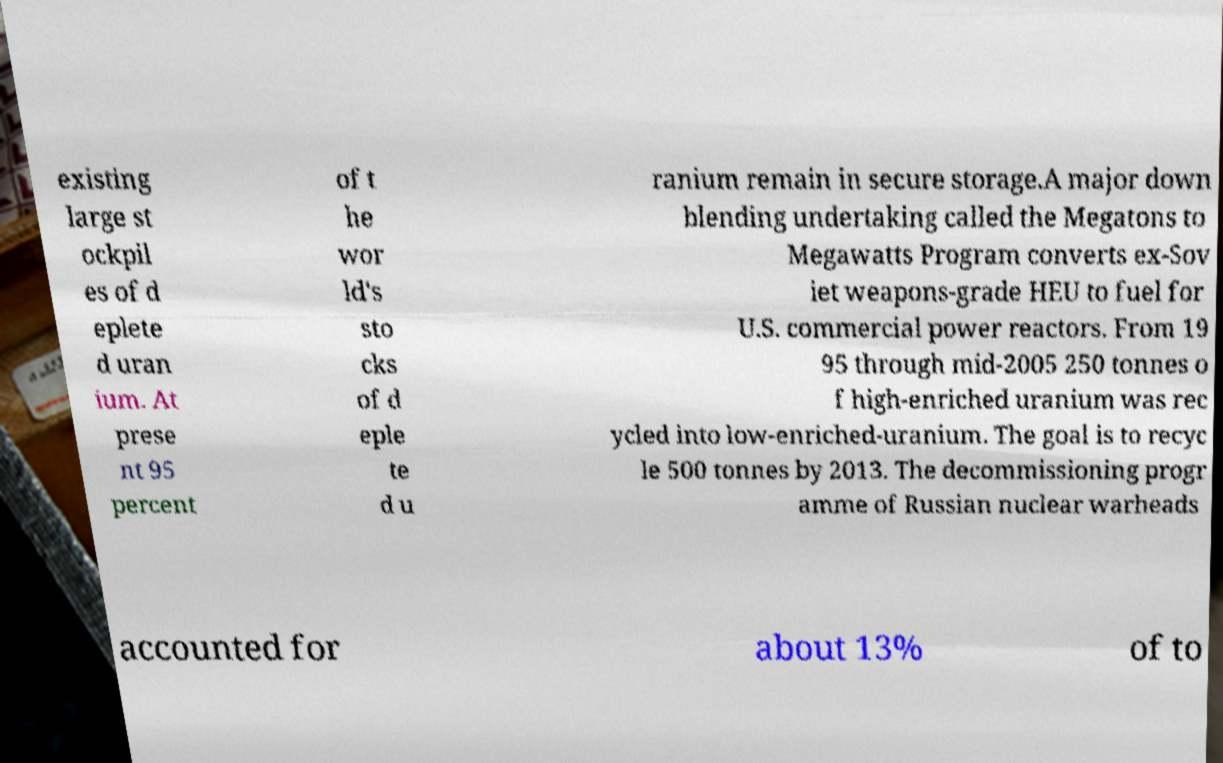There's text embedded in this image that I need extracted. Can you transcribe it verbatim? existing large st ockpil es of d eplete d uran ium. At prese nt 95 percent of t he wor ld's sto cks of d eple te d u ranium remain in secure storage.A major down blending undertaking called the Megatons to Megawatts Program converts ex-Sov iet weapons-grade HEU to fuel for U.S. commercial power reactors. From 19 95 through mid-2005 250 tonnes o f high-enriched uranium was rec ycled into low-enriched-uranium. The goal is to recyc le 500 tonnes by 2013. The decommissioning progr amme of Russian nuclear warheads accounted for about 13% of to 